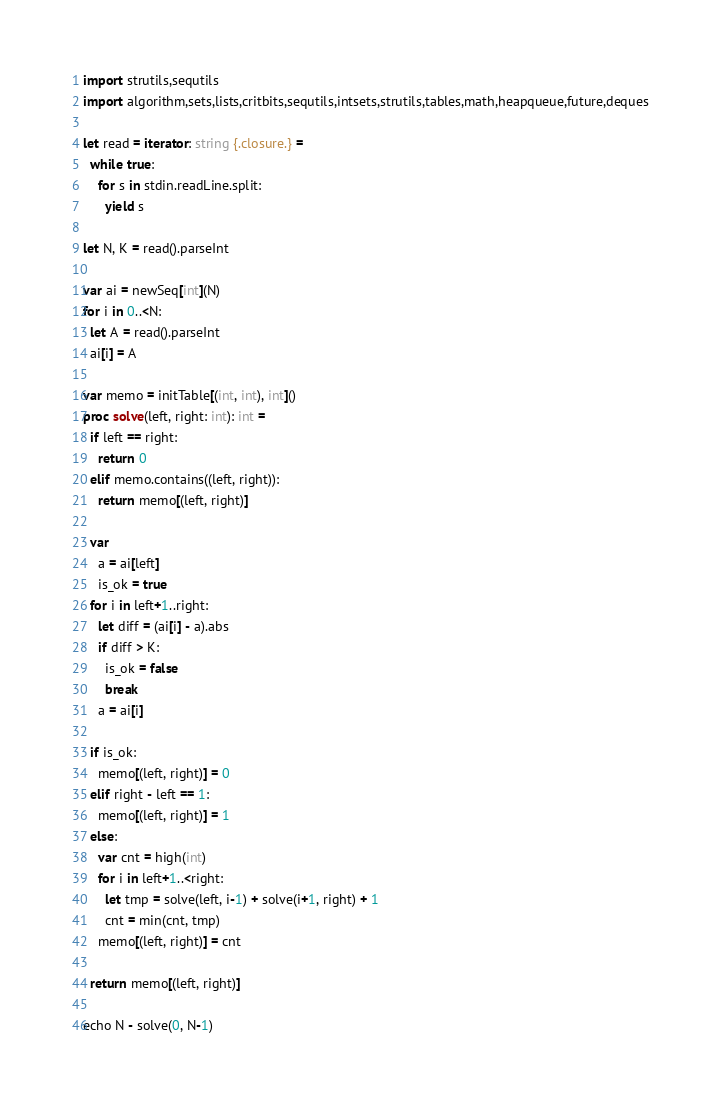<code> <loc_0><loc_0><loc_500><loc_500><_Nim_>import strutils,sequtils
import algorithm,sets,lists,critbits,sequtils,intsets,strutils,tables,math,heapqueue,future,deques

let read = iterator: string {.closure.} =
  while true:
    for s in stdin.readLine.split:
      yield s

let N, K = read().parseInt

var ai = newSeq[int](N)
for i in 0..<N:
  let A = read().parseInt
  ai[i] = A

var memo = initTable[(int, int), int]()
proc solve(left, right: int): int =
  if left == right:
    return 0
  elif memo.contains((left, right)):
    return memo[(left, right)]
  
  var
    a = ai[left]
    is_ok = true
  for i in left+1..right:
    let diff = (ai[i] - a).abs
    if diff > K:
      is_ok = false
      break
    a = ai[i]
  
  if is_ok:
    memo[(left, right)] = 0
  elif right - left == 1:
    memo[(left, right)] = 1
  else:
    var cnt = high(int)
    for i in left+1..<right:
      let tmp = solve(left, i-1) + solve(i+1, right) + 1
      cnt = min(cnt, tmp)
    memo[(left, right)] = cnt

  return memo[(left, right)]

echo N - solve(0, N-1)
</code> 